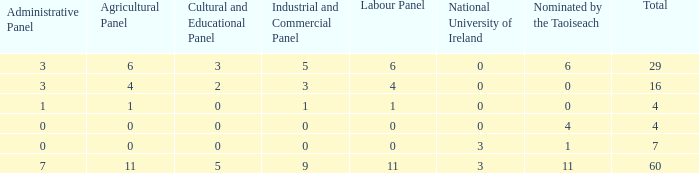What is the average agricultural panel of the composition with a labour panel less than 6, more than 0 nominations by Taoiseach, and a total less than 4? None. 